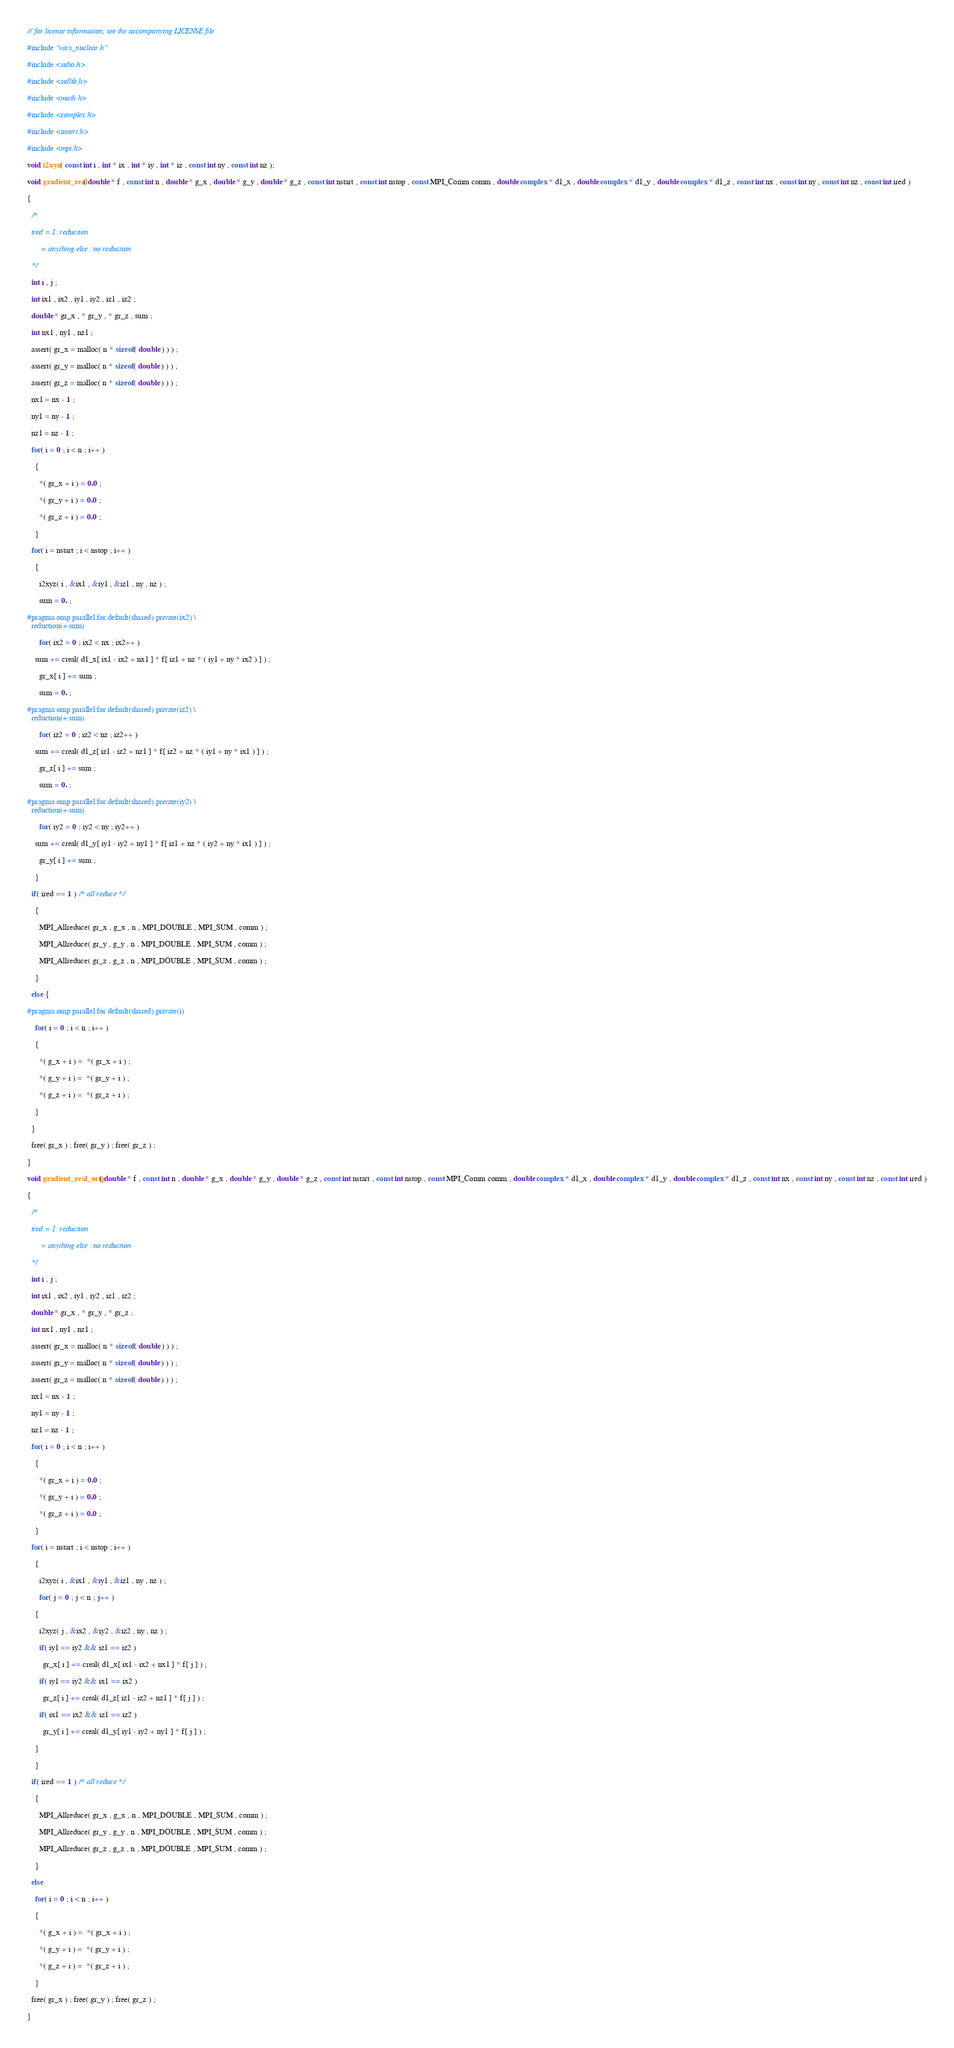Convert code to text. <code><loc_0><loc_0><loc_500><loc_500><_C_>// for license information, see the accompanying LICENSE file

#include "vars_nuclear.h"

#include <stdio.h>

#include <stdlib.h>

#include <math.h>

#include <complex.h>

#include <assert.h>

#include <mpi.h>

void i2xyz( const int i , int * ix , int * iy , int * iz , const int ny , const int nz );

void gradient_real( double * f , const int n , double * g_x , double * g_y , double * g_z , const int nstart , const int nstop , const MPI_Comm comm , double complex * d1_x , double complex * d1_y , double complex * d1_z , const int nx , const int ny , const int nz , const int ired )

{

  /* 

  ired = 1: reduction

       = anything else : no reduction

  */

  int i , j ;

  int ix1 , ix2 , iy1 , iy2 , iz1 , iz2 ;

  double * gr_x , * gr_y , * gr_z , sum ;

  int nx1 , ny1 , nz1 ;

  assert( gr_x = malloc( n * sizeof( double ) ) ) ;

  assert( gr_y = malloc( n * sizeof( double ) ) ) ;

  assert( gr_z = malloc( n * sizeof( double ) ) ) ;

  nx1 = nx - 1 ;

  ny1 = ny - 1 ;

  nz1 = nz - 1 ;

  for( i = 0 ; i < n ; i++ )

    {

      *( gr_x + i ) = 0.0 ;

      *( gr_y + i ) = 0.0 ;

      *( gr_z + i ) = 0.0 ;

    }

  for( i = nstart ; i < nstop ; i++ )

    {

      i2xyz( i , &ix1 , &iy1 , &iz1 , ny , nz ) ;

      sum = 0. ; 

#pragma omp parallel for default(shared) private(ix2) \
  reduction(+:sum) 

      for( ix2 = 0 ; ix2 < nx ; ix2++ )

	sum += creal( d1_x[ ix1 - ix2 + nx1 ] * f[ iz1 + nz * ( iy1 + ny * ix2 ) ] ) ;

      gr_x[ i ] += sum ;

      sum = 0. ;

#pragma omp parallel for default(shared) private(iz2) \
  reduction(+:sum) 

      for( iz2 = 0 ; iz2 < nz ; iz2++ )

	sum += creal( d1_z[ iz1 - iz2 + nz1 ] * f[ iz2 + nz * ( iy1 + ny * ix1 ) ] ) ;

      gr_z[ i ] += sum ;

      sum = 0. ;

#pragma omp parallel for default(shared) private(iy2) \
  reduction(+:sum) 

      for( iy2 = 0 ; iy2 < ny ; iy2++ )

	sum += creal( d1_y[ iy1 - iy2 + ny1 ] * f[ iz1 + nz * ( iy2 + ny * ix1 ) ] ) ;

      gr_y[ i ] += sum ;

    }

  if( ired == 1 ) /* all reduce */

    {
      
      MPI_Allreduce( gr_x , g_x , n , MPI_DOUBLE , MPI_SUM , comm ) ;

      MPI_Allreduce( gr_y , g_y , n , MPI_DOUBLE , MPI_SUM , comm ) ;

      MPI_Allreduce( gr_z , g_z , n , MPI_DOUBLE , MPI_SUM , comm ) ;

    }

  else {

#pragma omp parallel for default(shared) private(i)

    for( i = 0 ; i < n ; i++ )

	{

	  *( g_x + i ) =  *( gr_x + i ) ; 

	  *( g_y + i ) =  *( gr_y + i ) ; 

	  *( g_z + i ) =  *( gr_z + i ) ; 

	}

  }

  free( gr_x ) ; free( gr_y ) ; free( gr_z ) ;

}

void gradient_real_orig( double * f , const int n , double * g_x , double * g_y , double * g_z , const int nstart , const int nstop , const MPI_Comm comm , double complex * d1_x , double complex * d1_y , double complex * d1_z , const int nx , const int ny , const int nz , const int ired )

{

  /* 

  ired = 1: reduction

       = anything else : no reduction

  */

  int i , j ;

  int ix1 , ix2 , iy1 , iy2 , iz1 , iz2 ;

  double * gr_x , * gr_y , * gr_z ;

  int nx1 , ny1 , nz1 ;

  assert( gr_x = malloc( n * sizeof( double ) ) ) ;

  assert( gr_y = malloc( n * sizeof( double ) ) ) ;

  assert( gr_z = malloc( n * sizeof( double ) ) ) ;

  nx1 = nx - 1 ;

  ny1 = ny - 1 ;

  nz1 = nz - 1 ;

  for( i = 0 ; i < n ; i++ )

    {

      *( gr_x + i ) = 0.0 ;

      *( gr_y + i ) = 0.0 ;

      *( gr_z + i ) = 0.0 ;

    }

  for( i = nstart ; i < nstop ; i++ )

    {

      i2xyz( i , &ix1 , &iy1 , &iz1 , ny , nz ) ;

      for( j = 0 ; j < n ; j++ )

	{

	  i2xyz( j , &ix2 , &iy2 , &iz2 , ny , nz ) ;

	  if( iy1 == iy2 && iz1 == iz2 )

	    gr_x[ i ] += creal( d1_x[ ix1 - ix2 + nx1 ] * f[ j ] ) ;

	  if( iy1 == iy2 && ix1 == ix2 )

	    gr_z[ i ] += creal( d1_z[ iz1 - iz2 + nz1 ] * f[ j ] ) ;

	  if( ix1 == ix2 && iz1 == iz2 )

	    gr_y[ i ] += creal( d1_y[ iy1 - iy2 + ny1 ] * f[ j ] ) ;

	}

    }

  if( ired == 1 ) /* all reduce */

    {
      
      MPI_Allreduce( gr_x , g_x , n , MPI_DOUBLE , MPI_SUM , comm ) ;

      MPI_Allreduce( gr_y , g_y , n , MPI_DOUBLE , MPI_SUM , comm ) ;

      MPI_Allreduce( gr_z , g_z , n , MPI_DOUBLE , MPI_SUM , comm ) ;

    }

  else

    for( i = 0 ; i < n ; i++ )

	{

	  *( g_x + i ) =  *( gr_x + i ) ; 

	  *( g_y + i ) =  *( gr_y + i ) ; 

	  *( g_z + i ) =  *( gr_z + i ) ; 

	}

  free( gr_x ) ; free( gr_y ) ; free( gr_z ) ;

}
</code> 